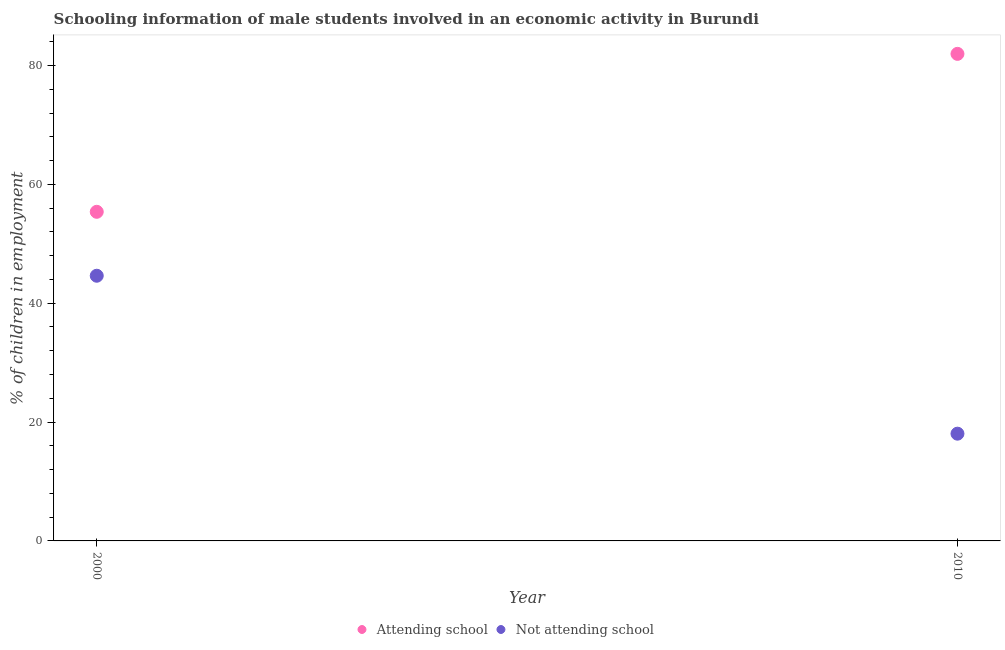Is the number of dotlines equal to the number of legend labels?
Offer a very short reply. Yes. What is the percentage of employed males who are not attending school in 2010?
Offer a very short reply. 18.04. Across all years, what is the maximum percentage of employed males who are attending school?
Provide a short and direct response. 81.96. Across all years, what is the minimum percentage of employed males who are attending school?
Your answer should be compact. 55.38. What is the total percentage of employed males who are not attending school in the graph?
Make the answer very short. 62.67. What is the difference between the percentage of employed males who are not attending school in 2000 and that in 2010?
Make the answer very short. 26.58. What is the difference between the percentage of employed males who are not attending school in 2010 and the percentage of employed males who are attending school in 2000?
Provide a succinct answer. -37.33. What is the average percentage of employed males who are not attending school per year?
Your answer should be compact. 31.33. In the year 2000, what is the difference between the percentage of employed males who are attending school and percentage of employed males who are not attending school?
Make the answer very short. 10.76. What is the ratio of the percentage of employed males who are attending school in 2000 to that in 2010?
Make the answer very short. 0.68. Is the percentage of employed males who are not attending school in 2000 less than that in 2010?
Give a very brief answer. No. In how many years, is the percentage of employed males who are not attending school greater than the average percentage of employed males who are not attending school taken over all years?
Offer a terse response. 1. Is the percentage of employed males who are attending school strictly greater than the percentage of employed males who are not attending school over the years?
Provide a short and direct response. Yes. How many dotlines are there?
Provide a short and direct response. 2. How many years are there in the graph?
Offer a terse response. 2. Does the graph contain grids?
Keep it short and to the point. No. How many legend labels are there?
Provide a short and direct response. 2. How are the legend labels stacked?
Ensure brevity in your answer.  Horizontal. What is the title of the graph?
Ensure brevity in your answer.  Schooling information of male students involved in an economic activity in Burundi. Does "Constant 2005 US$" appear as one of the legend labels in the graph?
Ensure brevity in your answer.  No. What is the label or title of the Y-axis?
Give a very brief answer. % of children in employment. What is the % of children in employment of Attending school in 2000?
Provide a succinct answer. 55.38. What is the % of children in employment of Not attending school in 2000?
Provide a succinct answer. 44.62. What is the % of children in employment in Attending school in 2010?
Ensure brevity in your answer.  81.96. What is the % of children in employment in Not attending school in 2010?
Make the answer very short. 18.04. Across all years, what is the maximum % of children in employment in Attending school?
Ensure brevity in your answer.  81.96. Across all years, what is the maximum % of children in employment in Not attending school?
Your response must be concise. 44.62. Across all years, what is the minimum % of children in employment in Attending school?
Your answer should be very brief. 55.38. Across all years, what is the minimum % of children in employment in Not attending school?
Give a very brief answer. 18.04. What is the total % of children in employment of Attending school in the graph?
Provide a short and direct response. 137.33. What is the total % of children in employment of Not attending school in the graph?
Offer a very short reply. 62.67. What is the difference between the % of children in employment of Attending school in 2000 and that in 2010?
Keep it short and to the point. -26.58. What is the difference between the % of children in employment in Not attending school in 2000 and that in 2010?
Your answer should be compact. 26.58. What is the difference between the % of children in employment in Attending school in 2000 and the % of children in employment in Not attending school in 2010?
Provide a succinct answer. 37.33. What is the average % of children in employment in Attending school per year?
Ensure brevity in your answer.  68.67. What is the average % of children in employment in Not attending school per year?
Your response must be concise. 31.33. In the year 2000, what is the difference between the % of children in employment in Attending school and % of children in employment in Not attending school?
Your response must be concise. 10.76. In the year 2010, what is the difference between the % of children in employment in Attending school and % of children in employment in Not attending school?
Offer a very short reply. 63.91. What is the ratio of the % of children in employment in Attending school in 2000 to that in 2010?
Offer a very short reply. 0.68. What is the ratio of the % of children in employment in Not attending school in 2000 to that in 2010?
Your response must be concise. 2.47. What is the difference between the highest and the second highest % of children in employment of Attending school?
Your answer should be compact. 26.58. What is the difference between the highest and the second highest % of children in employment in Not attending school?
Offer a terse response. 26.58. What is the difference between the highest and the lowest % of children in employment of Attending school?
Make the answer very short. 26.58. What is the difference between the highest and the lowest % of children in employment of Not attending school?
Your answer should be very brief. 26.58. 